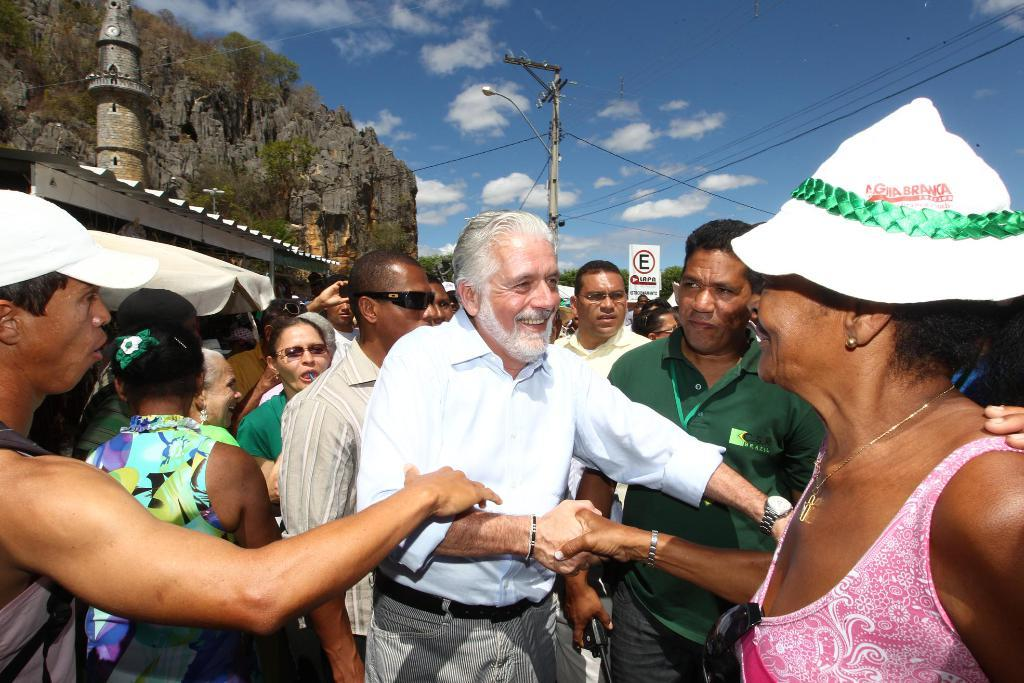What are the people in the image doing? The people in the image are standing and smiling. What can be seen in the background of the image? In the background of the image, there are hills, poles, sign boards, and trees. What is visible at the top of the image? The sky is visible at the top of the image, and there are clouds in the sky. What type of lace can be seen on the sign boards in the image? There is no lace present on the sign boards in the image. What nation are the people in the image from? The provided facts do not mention the nationality of the people in the image. 